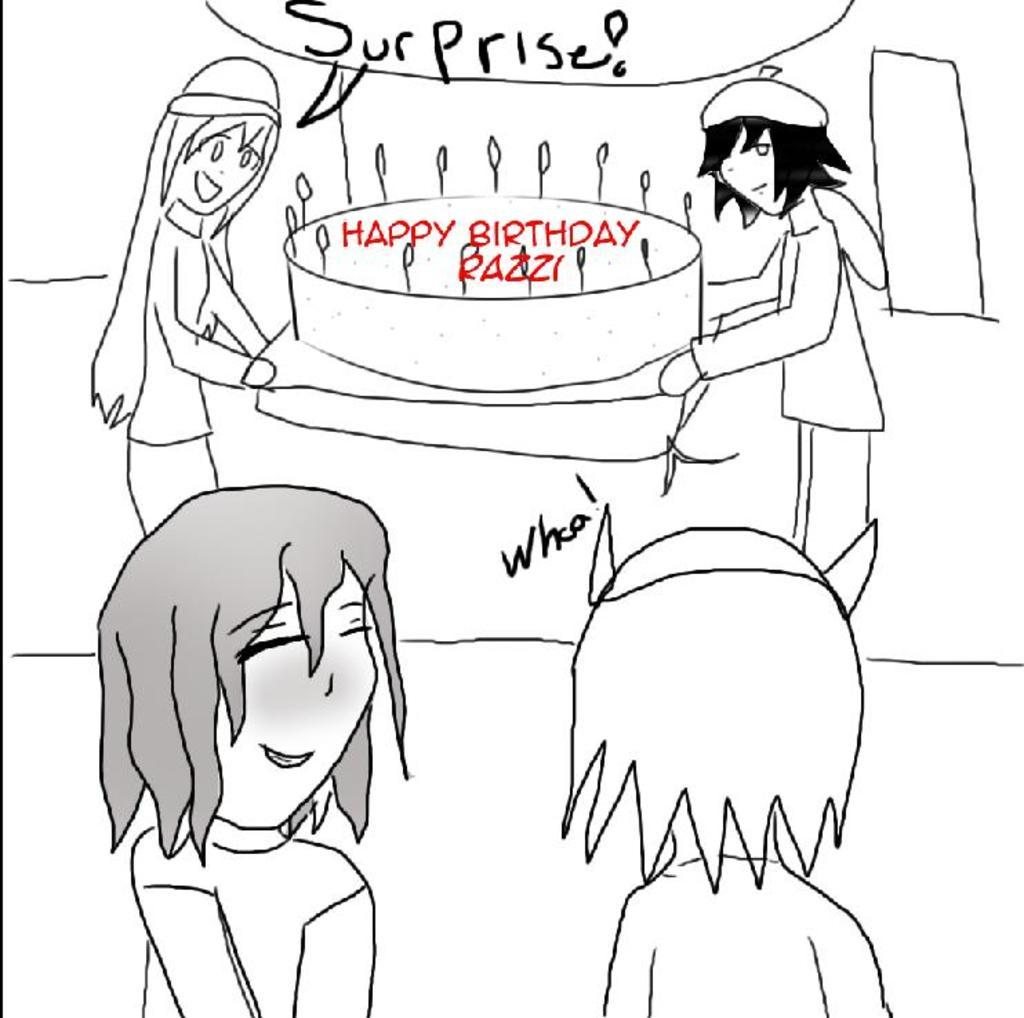What is present in the image besides the persons? There is a cake in the image. Can you describe any text that is visible in the image? Yes, there is some text in the image. What type of needle is being used to decorate the cake in the image? There is no needle present in the image, and the cake does not appear to be decorated. What type of ornament is hanging from the ceiling in the image? There is no ornament hanging from the ceiling in the image. 